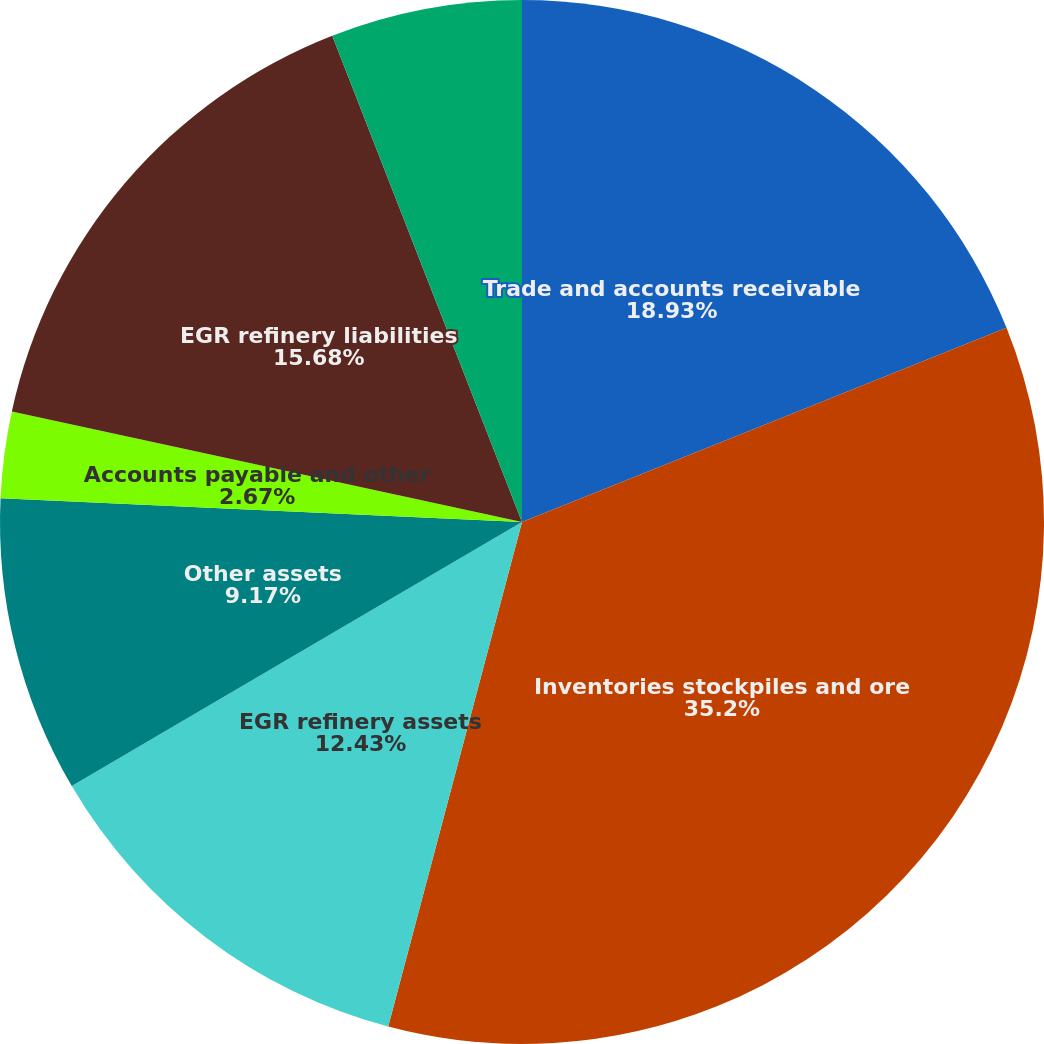Convert chart to OTSL. <chart><loc_0><loc_0><loc_500><loc_500><pie_chart><fcel>Trade and accounts receivable<fcel>Inventories stockpiles and ore<fcel>EGR refinery assets<fcel>Other assets<fcel>Accounts payable and other<fcel>EGR refinery liabilities<fcel>Reclamation liabilities<nl><fcel>18.93%<fcel>35.19%<fcel>12.43%<fcel>9.17%<fcel>2.67%<fcel>15.68%<fcel>5.92%<nl></chart> 